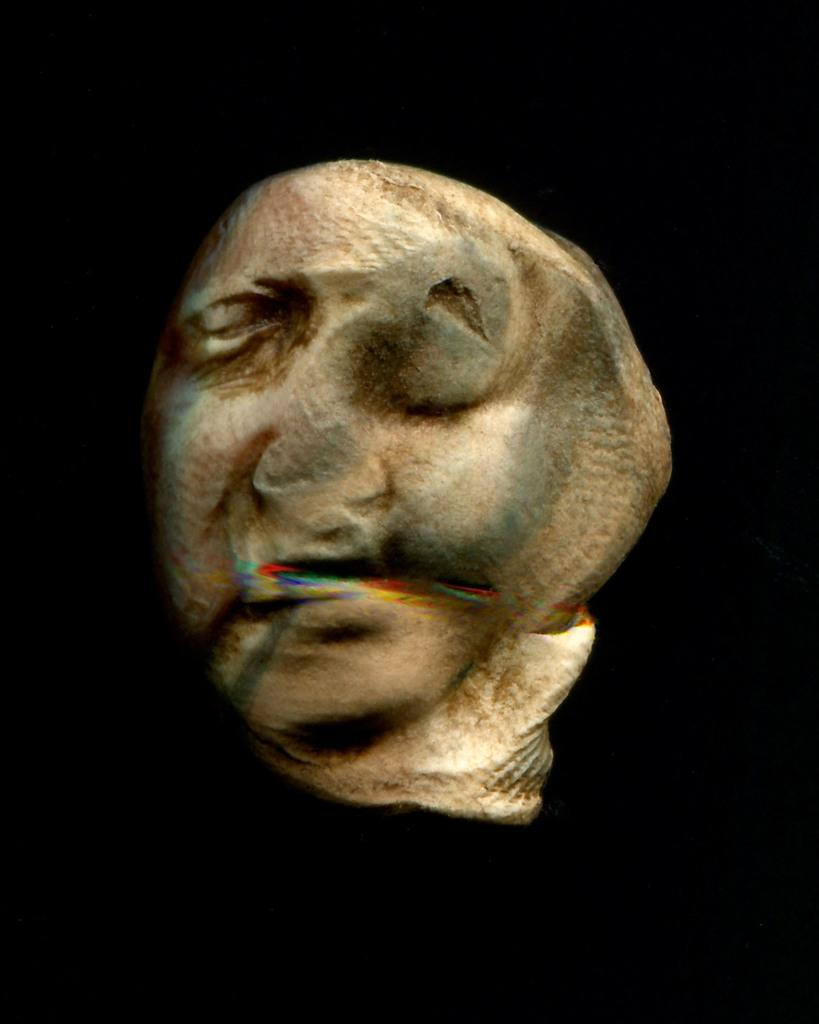What is the main subject of the image? There is a sculpture in the center of the image. What can be seen in the background of the image? The background of the image is dark. How many books are being cooked by the drain in the image? There are no books or drains present in the image; it features a sculpture with a dark background. 